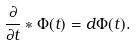<formula> <loc_0><loc_0><loc_500><loc_500>\frac { \partial } { \partial t } * \Phi ( t ) = d \Phi ( t ) .</formula> 